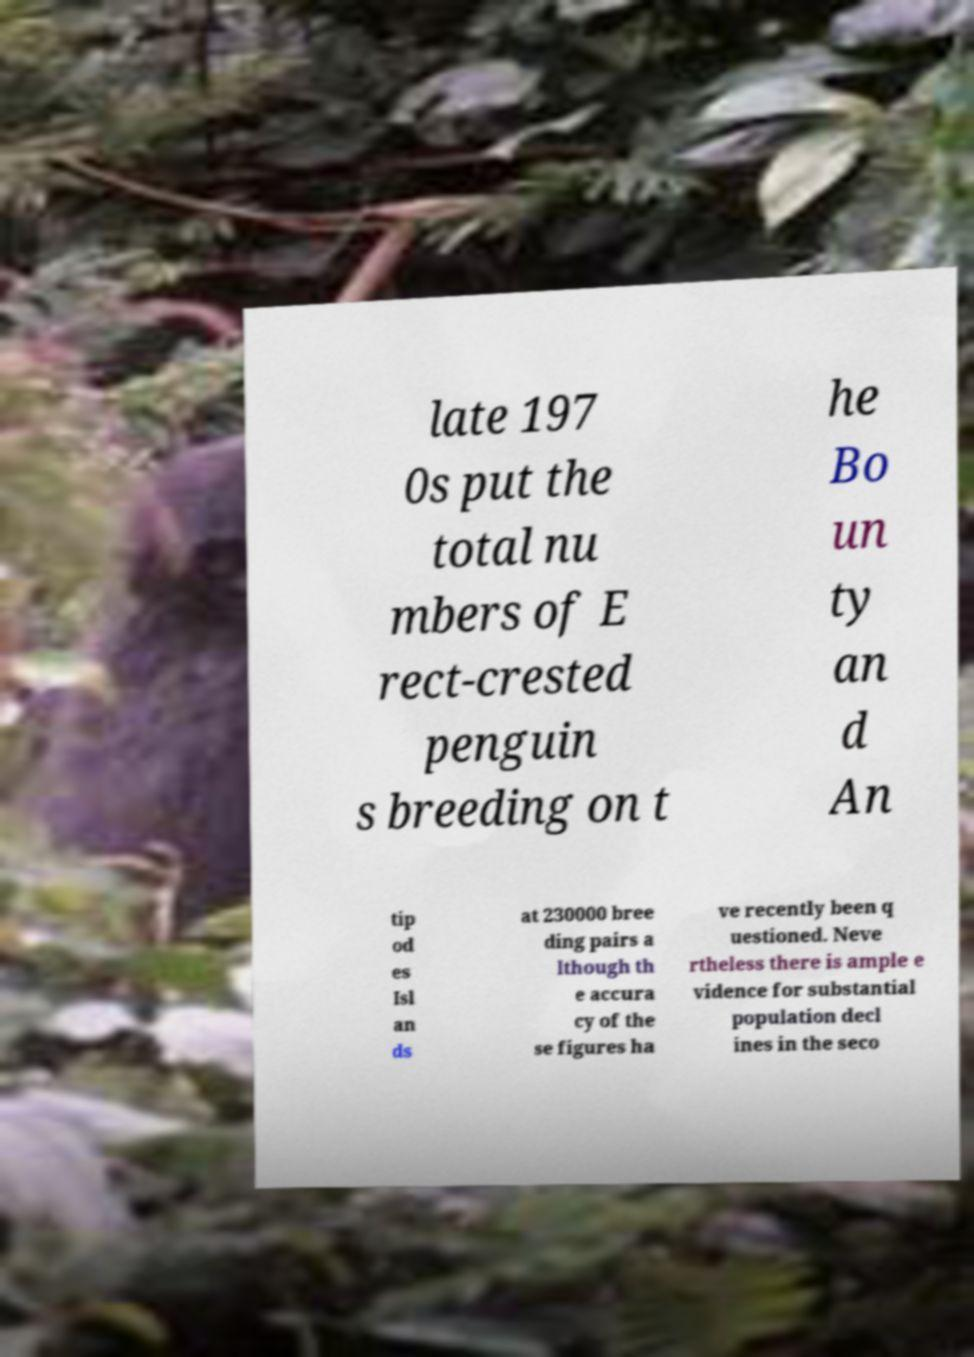Could you assist in decoding the text presented in this image and type it out clearly? late 197 0s put the total nu mbers of E rect-crested penguin s breeding on t he Bo un ty an d An tip od es Isl an ds at 230000 bree ding pairs a lthough th e accura cy of the se figures ha ve recently been q uestioned. Neve rtheless there is ample e vidence for substantial population decl ines in the seco 